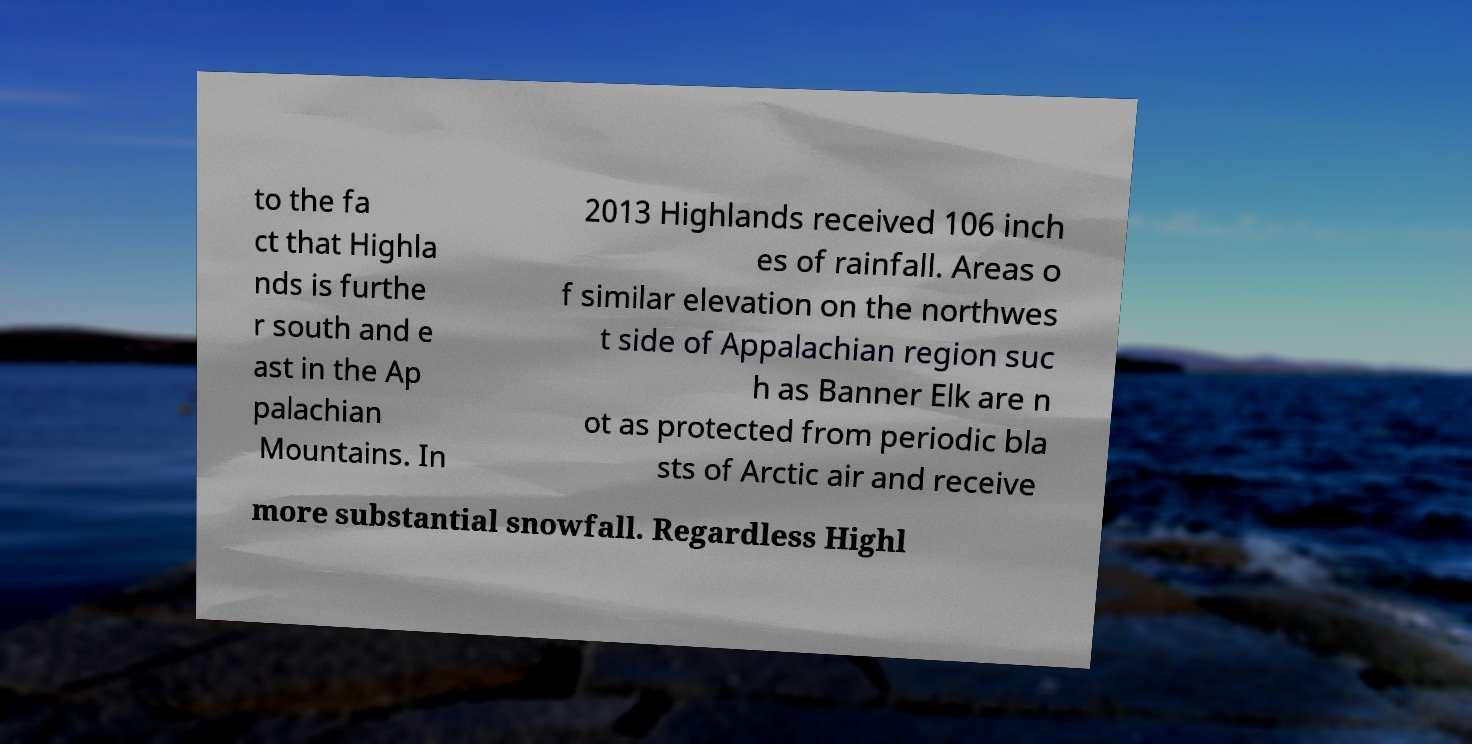Please read and relay the text visible in this image. What does it say? to the fa ct that Highla nds is furthe r south and e ast in the Ap palachian Mountains. In 2013 Highlands received 106 inch es of rainfall. Areas o f similar elevation on the northwes t side of Appalachian region suc h as Banner Elk are n ot as protected from periodic bla sts of Arctic air and receive more substantial snowfall. Regardless Highl 